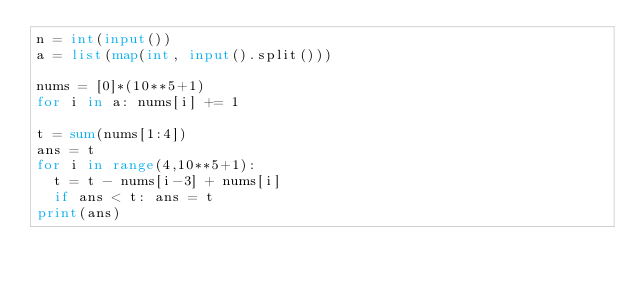<code> <loc_0><loc_0><loc_500><loc_500><_Python_>n = int(input())
a = list(map(int, input().split()))

nums = [0]*(10**5+1)
for i in a: nums[i] += 1

t = sum(nums[1:4])
ans = t
for i in range(4,10**5+1):
  t = t - nums[i-3] + nums[i]
  if ans < t: ans = t
print(ans)</code> 